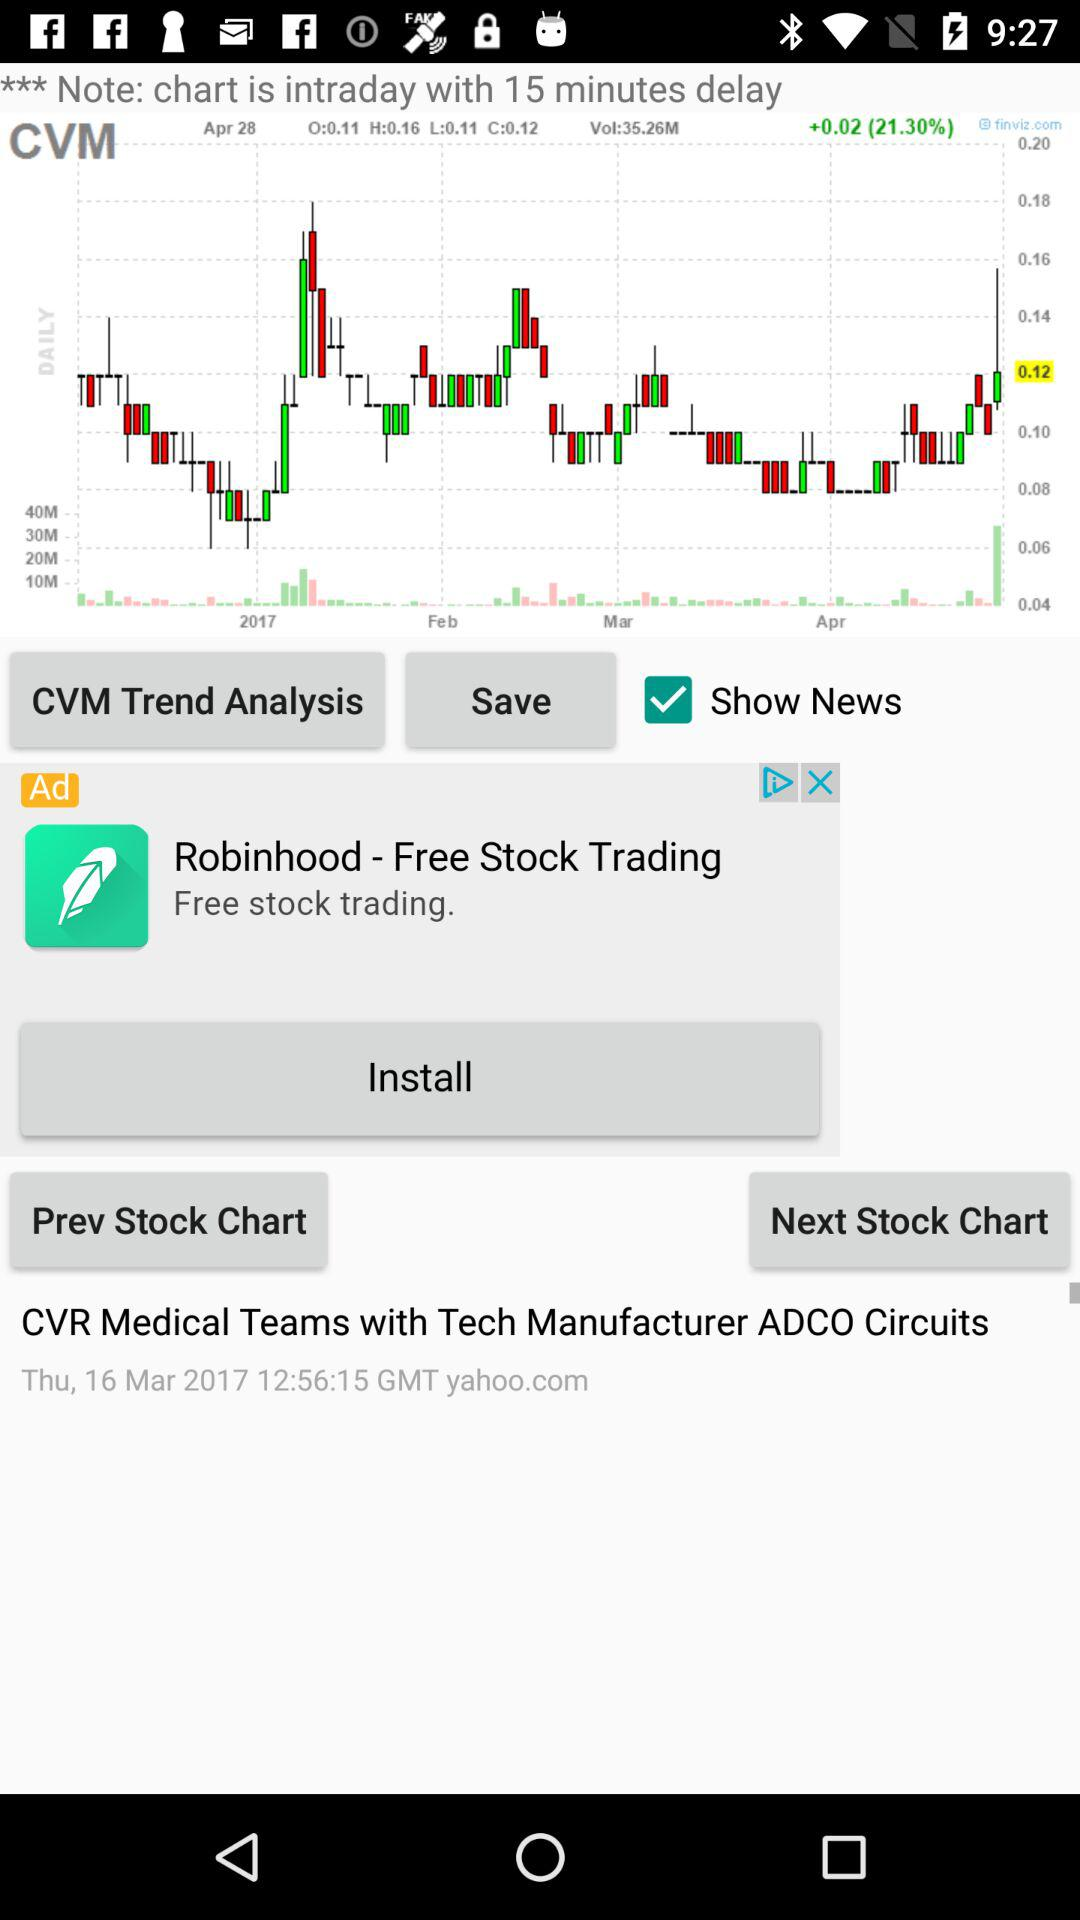What is the given date for "CVR Medical Teams with Tech Manufacturer ADCO Circuits"? The date is Thursday, March 16, 2017. 